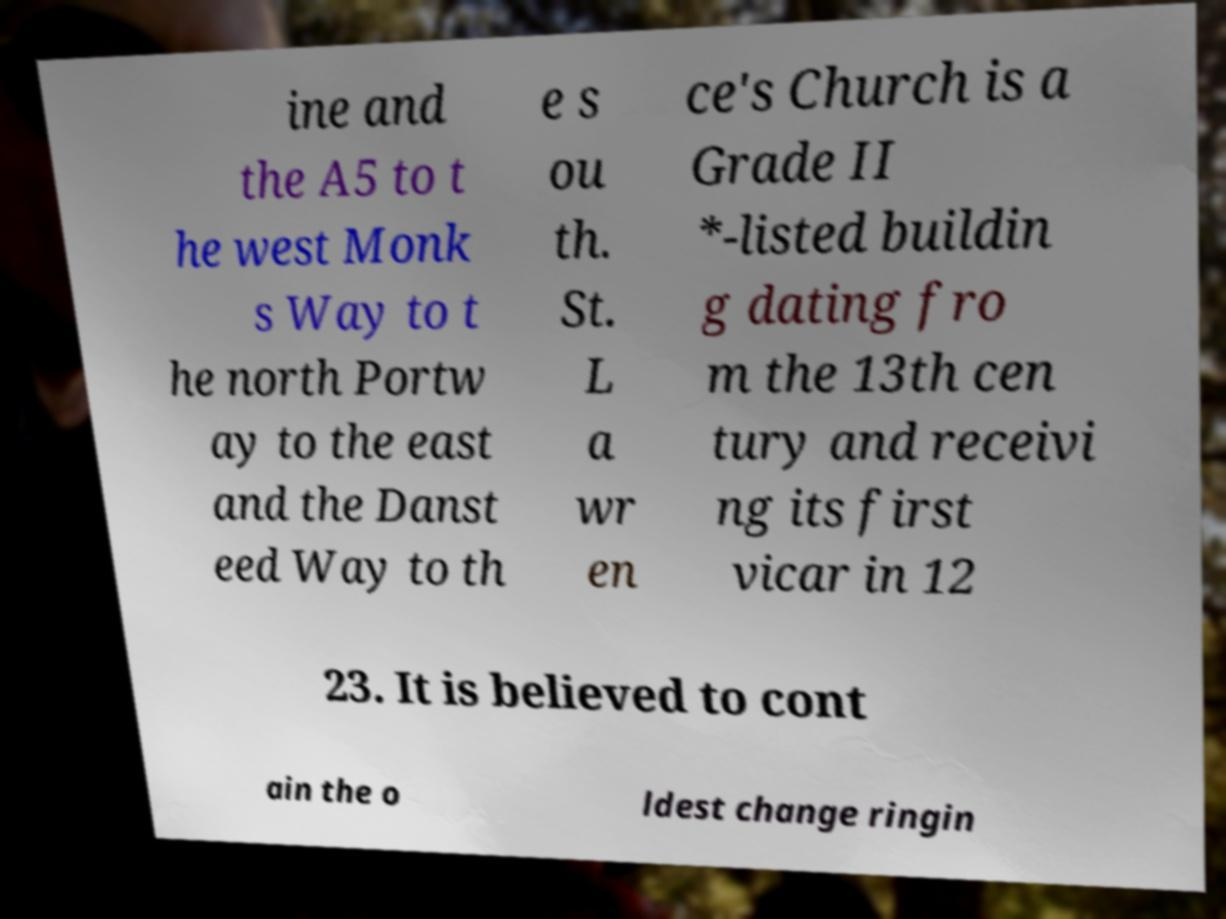Could you assist in decoding the text presented in this image and type it out clearly? ine and the A5 to t he west Monk s Way to t he north Portw ay to the east and the Danst eed Way to th e s ou th. St. L a wr en ce's Church is a Grade II *-listed buildin g dating fro m the 13th cen tury and receivi ng its first vicar in 12 23. It is believed to cont ain the o ldest change ringin 